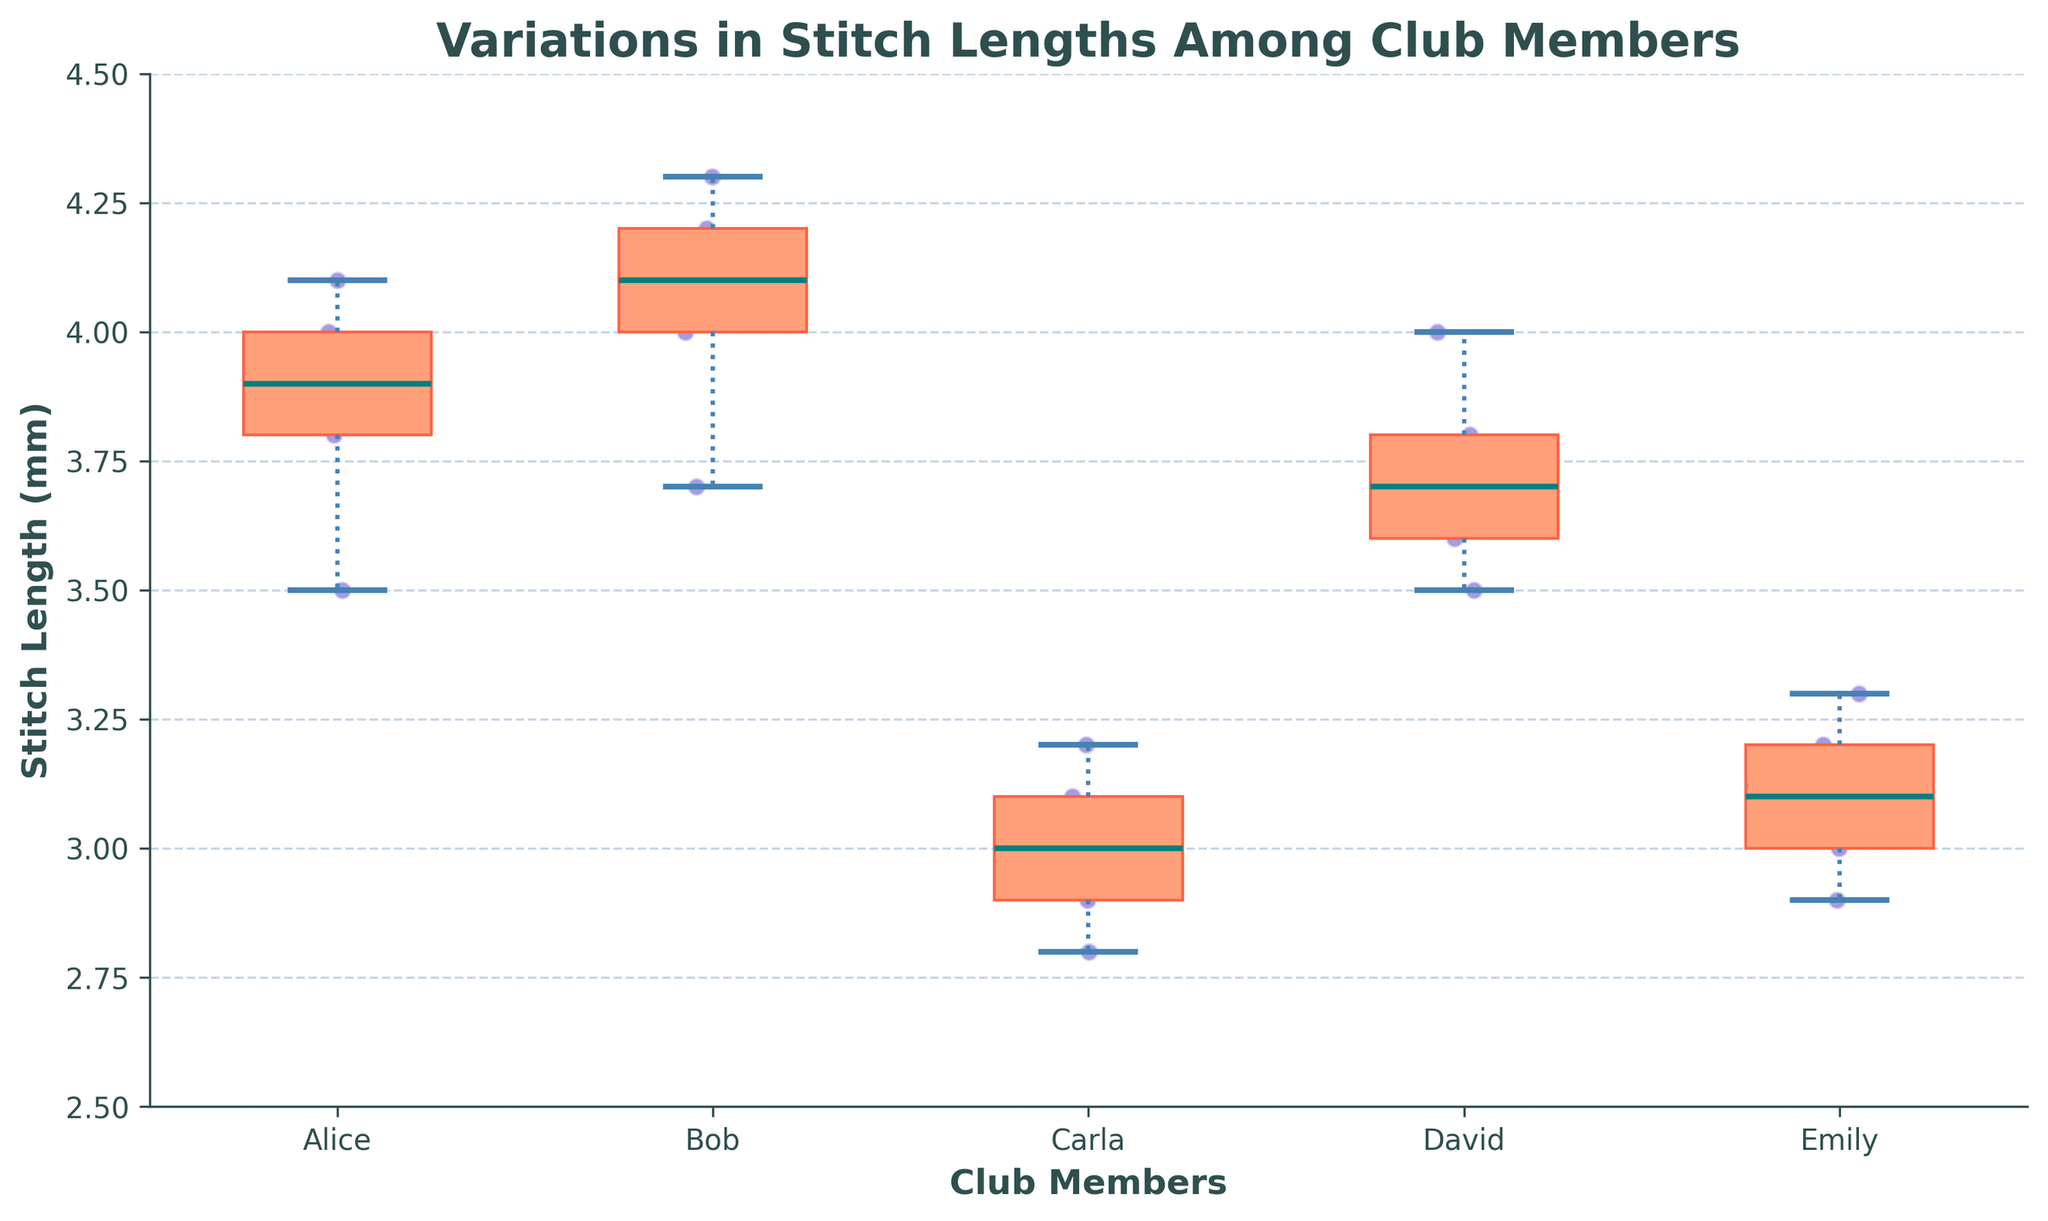What is the title of the plot? The title of the plot is displayed at the top and it reads "Variations in Stitch Lengths Among Club Members"
Answer: Variations in Stitch Lengths Among Club Members Which member has the highest median stitch length? The median stitch length is indicated by the line inside the box of each box plot. The member with the highest median stitch length is Bob.
Answer: Bob What is the range of stitch lengths for Alice? The range of stitch lengths is the difference between the maximum and minimum whiskers for Alice's box plot. Alice's stitch lengths range from approximately 3.5 to 4.1mm.
Answer: 3.5 to 4.1mm How many members have median stitch lengths above 3.5mm? By checking the line inside each box plot, we can identify that Alice, Bob, David, and Emily each have median stitch lengths above 3.5mm.
Answer: 4 members Which member exhibits the most variation in stitch lengths? The member with the largest interquartile range (distance between the top and bottom of the box) shows the most variation. Carla shows the widest box plot, indicating the most variation.
Answer: Carla What is the approximate median stitch length of Emily? The median stitch length is indicated by the line inside the box of Emily's box plot, which is approximately 3.1mm.
Answer: 3.1mm Which member has outliers in their stitch lengths? Outliers are represented by scatter points outside the whiskers of the box plot. Bob and David have some scatter points outside their whiskers.
Answer: Bob and David Compare David's interquartile range with Emily's. Who has a larger interquartile range? The interquartile range is the distance between the top and bottom of the box. David's box is taller than Emily's, indicating that David has a larger interquartile range.
Answer: David What is the color of the scatter points representing stitch lengths? The scatter points are represented in a deep blue or similar shade, matching the color scheme used in the plot.
Answer: Deep blue What is the approximate mean stitch length for Bob? To find the mean, add Bob's stitch lengths: 4.2 + 3.7 + 4.1 + 4.0 + 4.3 = 20.3, then divide by the number of data points, which is 5. The mean is 20.3 / 5 = 4.06
Answer: 4.06 